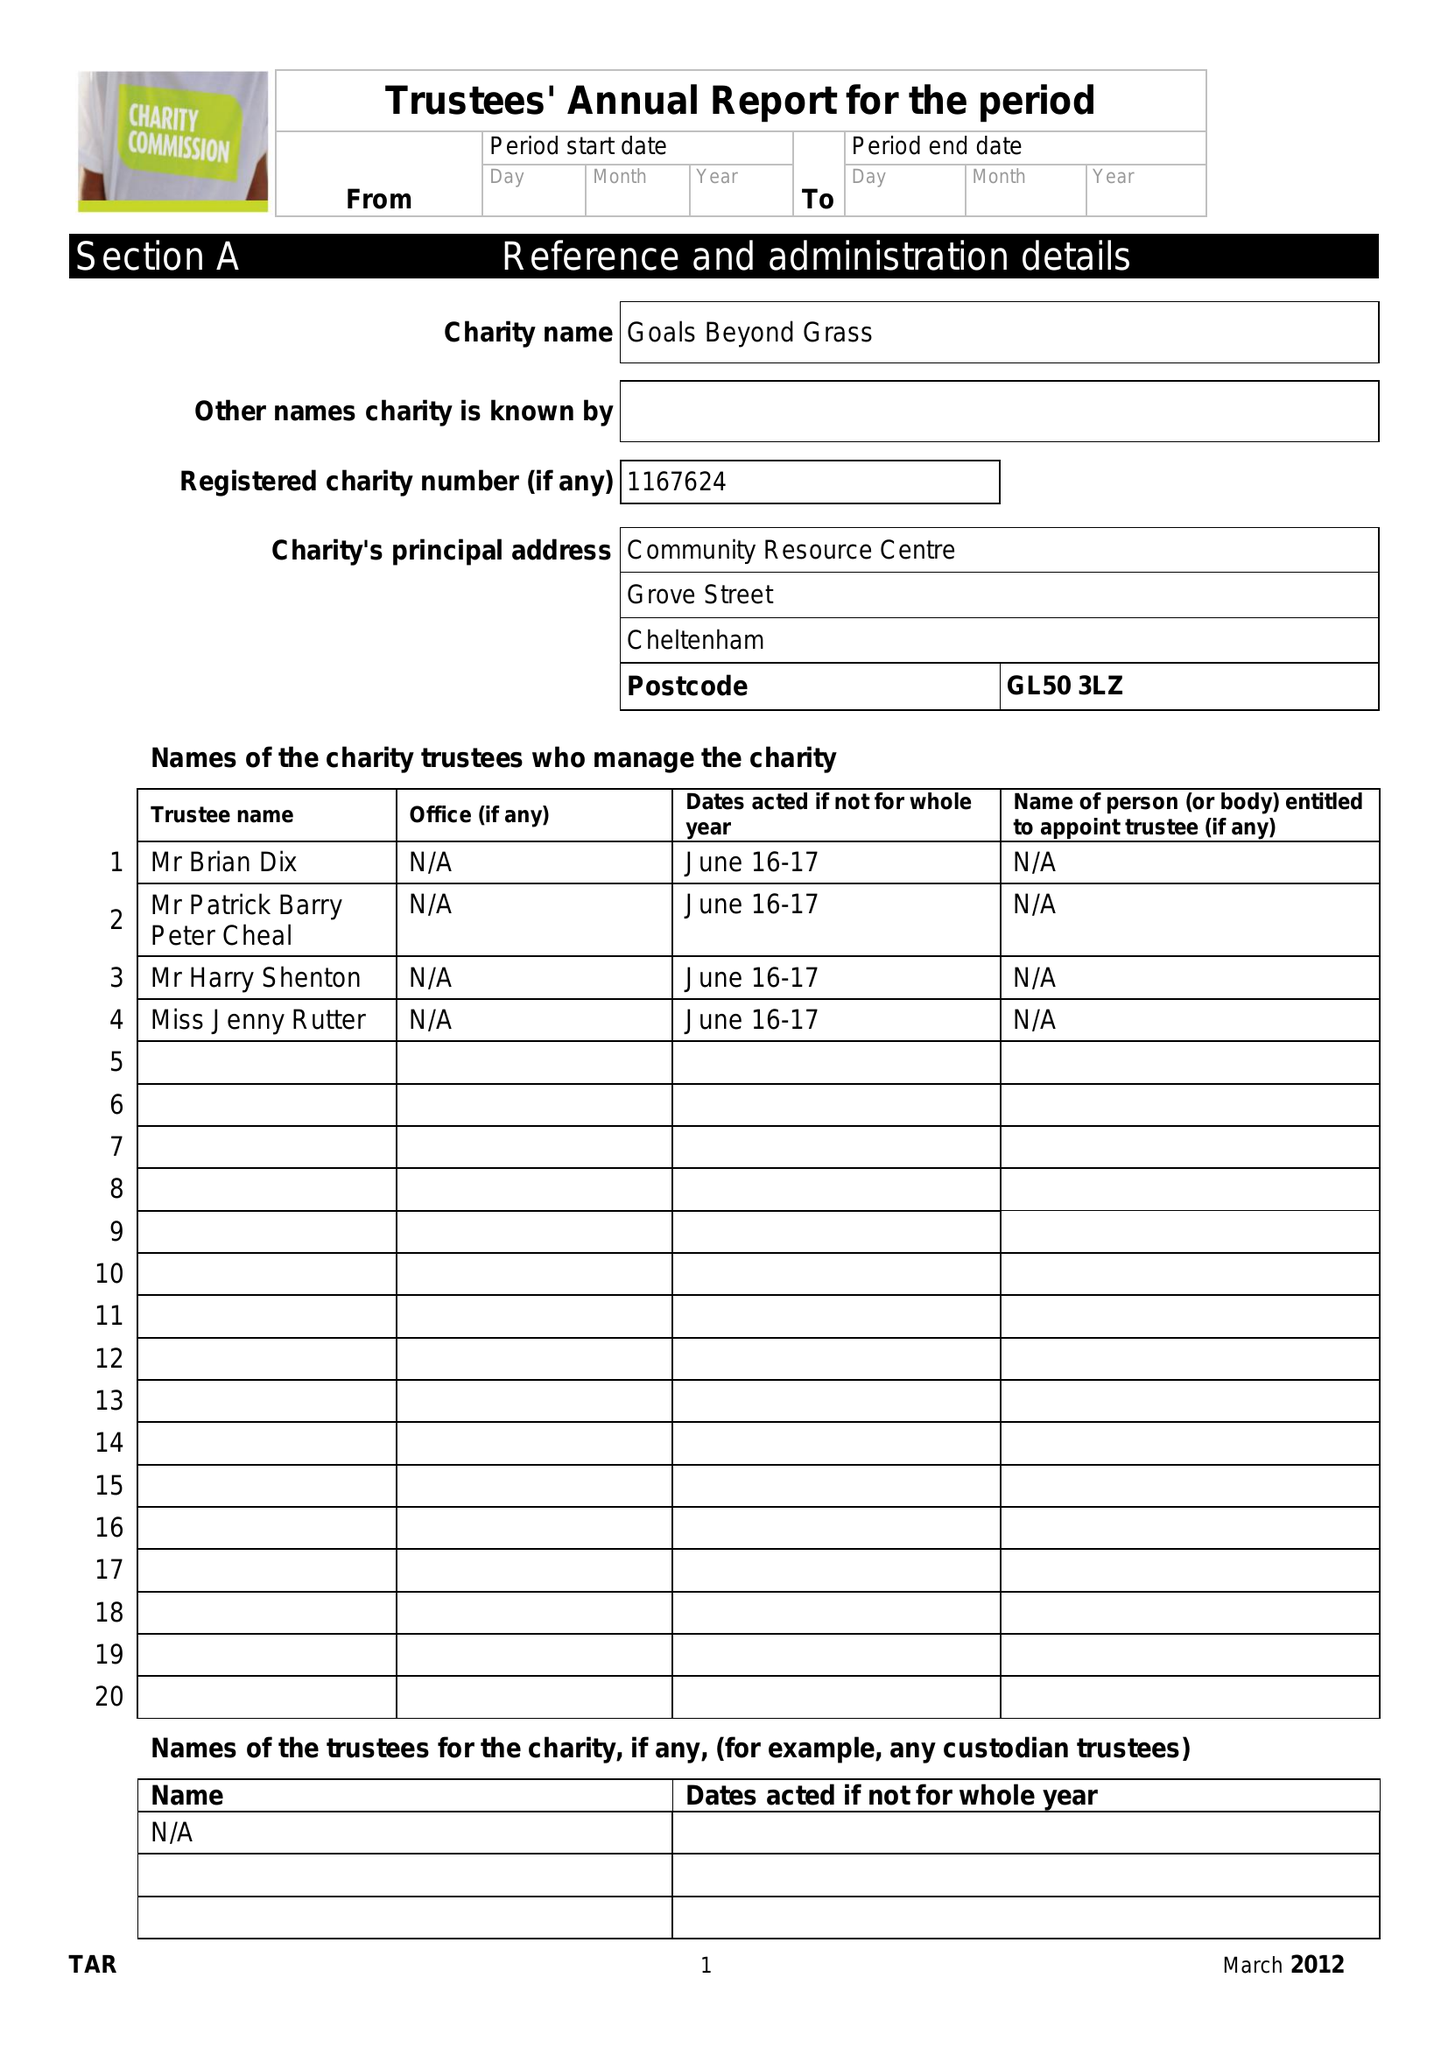What is the value for the charity_name?
Answer the question using a single word or phrase. Goals Beyond Grass 